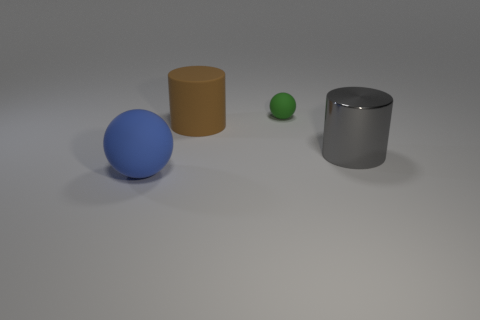Subtract all brown cylinders. How many cylinders are left? 1 Subtract 1 spheres. How many spheres are left? 1 Add 4 green shiny blocks. How many objects exist? 8 Subtract all blue balls. How many cyan cylinders are left? 0 Subtract all yellow objects. Subtract all big rubber objects. How many objects are left? 2 Add 1 big brown things. How many big brown things are left? 2 Add 3 blue matte objects. How many blue matte objects exist? 4 Subtract 0 purple balls. How many objects are left? 4 Subtract all gray cylinders. Subtract all purple balls. How many cylinders are left? 1 